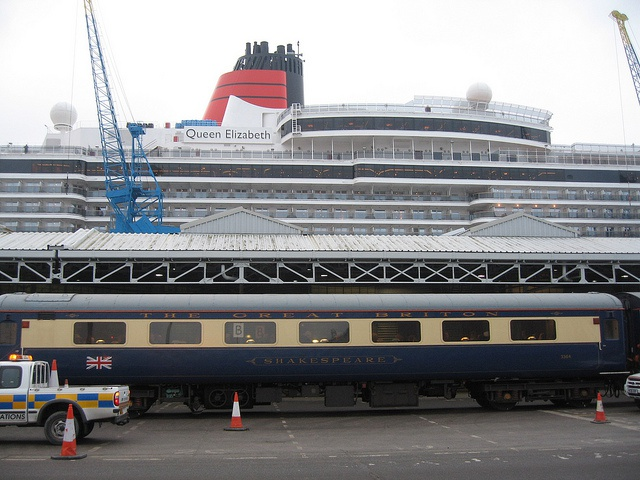Describe the objects in this image and their specific colors. I can see boat in white, gray, darkgray, lightgray, and black tones, train in white, black, darkgray, gray, and tan tones, boat in white, lightgray, gray, darkgray, and salmon tones, truck in white, black, gray, darkgray, and olive tones, and car in white, gray, black, and darkgray tones in this image. 